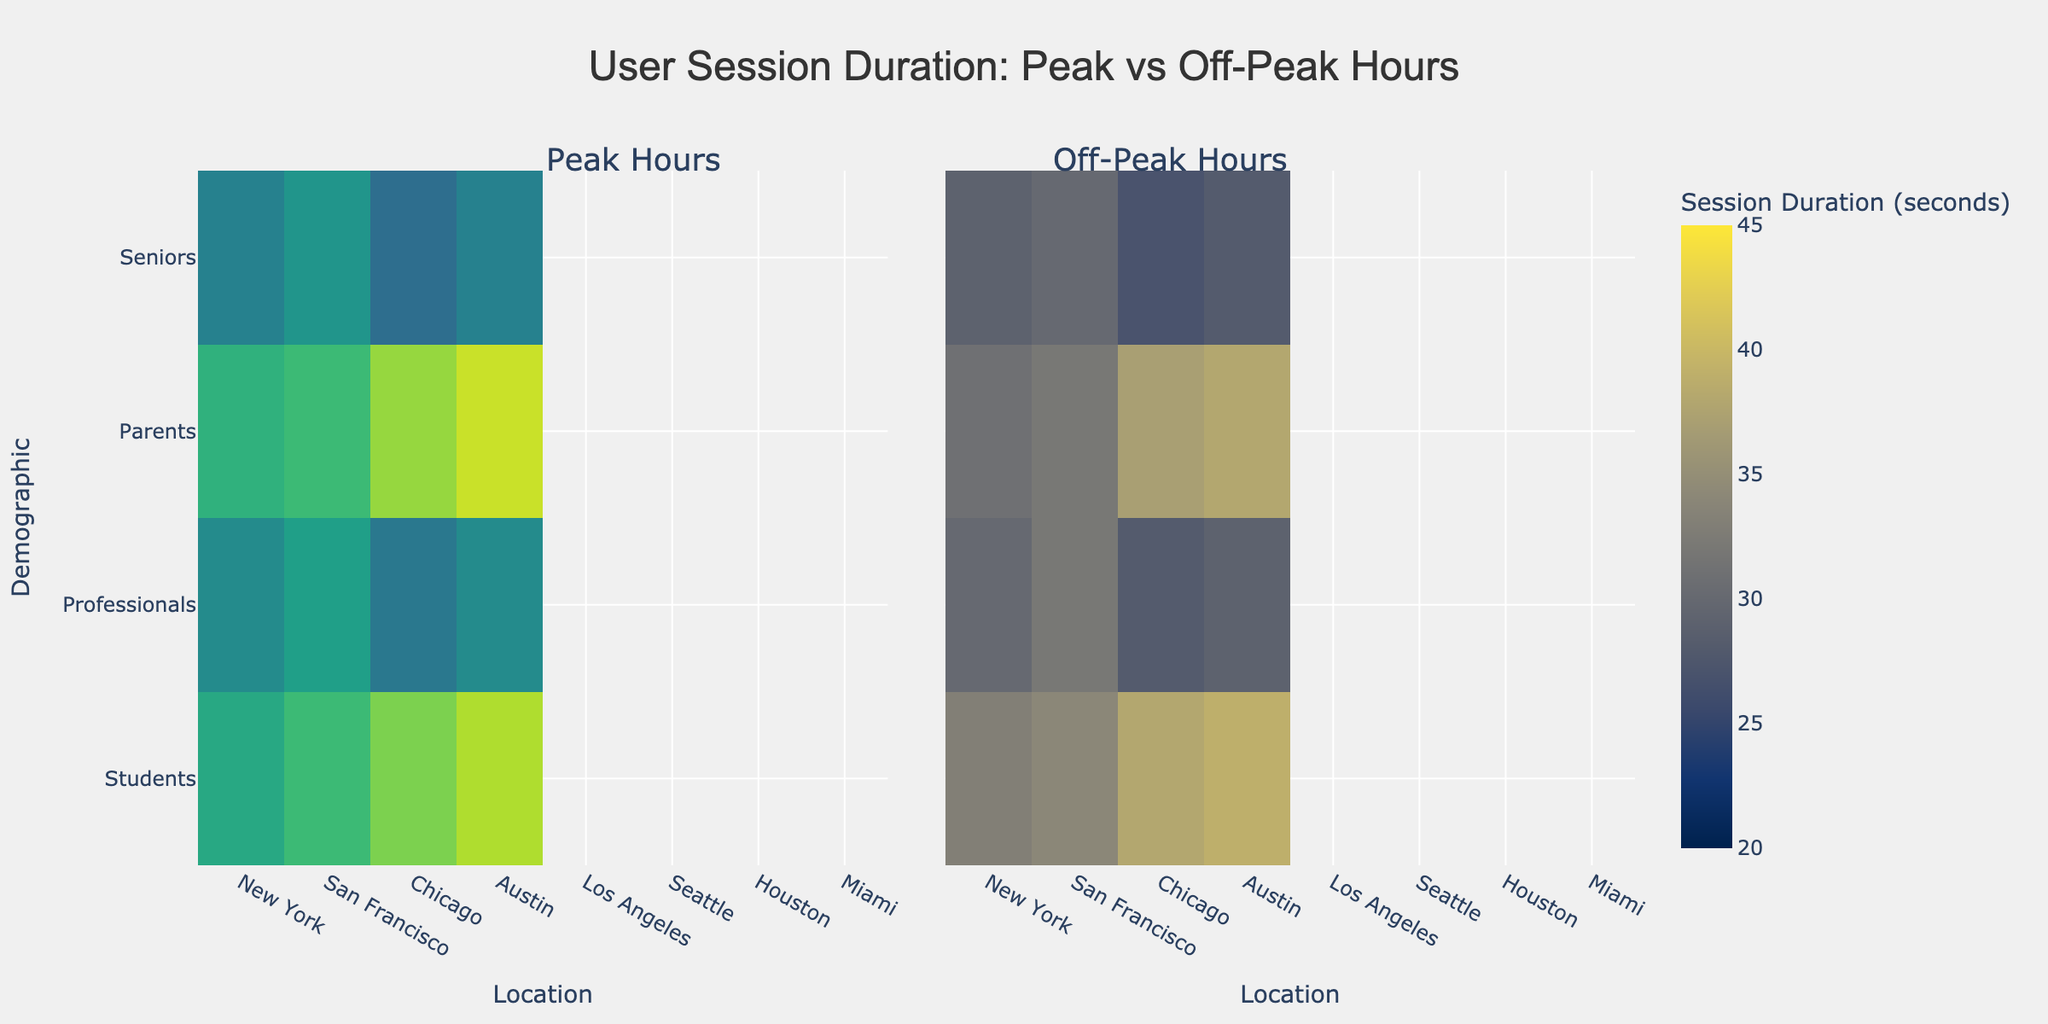How are the x-axes labeled in the figure? The x-axes in the figure are labeled with the location names, such as New York, San Francisco, Chicago, etc. On the left, we have locations for peak hours, and on the right, for off-peak hours.
Answer: Location names Which demographic group has the highest session duration during peak hours in Austin? To determine this, look at the heatmap for peak hours and find the session duration for each demographic in Austin. The highest value corresponds to the demographic "Seniors, Female" with a duration of 42 seconds.
Answer: Seniors, Female What is the average session duration during off-peak hours for professionals in Seattle? First, find the session durations for both male and female professionals in Seattle during off-peak hours from the heatmap. These are 37 and 38 seconds, respectively. The average duration is (37 + 38) / 2 = 37.5 seconds.
Answer: 37.5 seconds How does the session duration of parents in Chicago during peak hours compare to off-peak hours? Look at the heatmap values for parents in Chicago during both peak and off-peak hours. The session durations are 42 and 30 seconds, respectively. Peak hours have a higher duration by (42 - 30) = 12 seconds.
Answer: 12 seconds higher Which location has the maximum difference in session duration for students between peak and off-peak hours? To find the location with the maximum difference, calculate the difference for each city for students. New York: (45-33) = 12, Los Angeles: (46-31) = 15. Los Angeles has the maximum difference of 15 seconds.
Answer: Los Angeles In which location do seniors have the highest session duration during off-peak hours? Examine the off-peak hour heatmap for seniors and compare the durations for each location. The highest value is in Austin with 29 seconds for females.
Answer: Austin What is the session duration difference between male and female professionals in San Francisco during peak hours? For professionals in San Francisco, locate the session durations for males and females during peak hours. Males: 50 seconds, Females: 52 seconds. The difference is (52 - 50) = 2 seconds.
Answer: 2 seconds Which gender has a shorter average session duration during peak hours across all demographics? Calculate the average session duration for males and females during peak hours by summing their session durations and dividing by the count. Males total: 45+50+42+40+46+51+41+39 = 354, average = 354/8 = 44.25 seconds. Females total: 47+52+44+42+47+53+43+41 = 369, average = 369/8 = 46.125 seconds. Males have a shorter average duration.
Answer: Males 